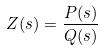<formula> <loc_0><loc_0><loc_500><loc_500>Z ( s ) = \frac { P ( s ) } { Q ( s ) }</formula> 